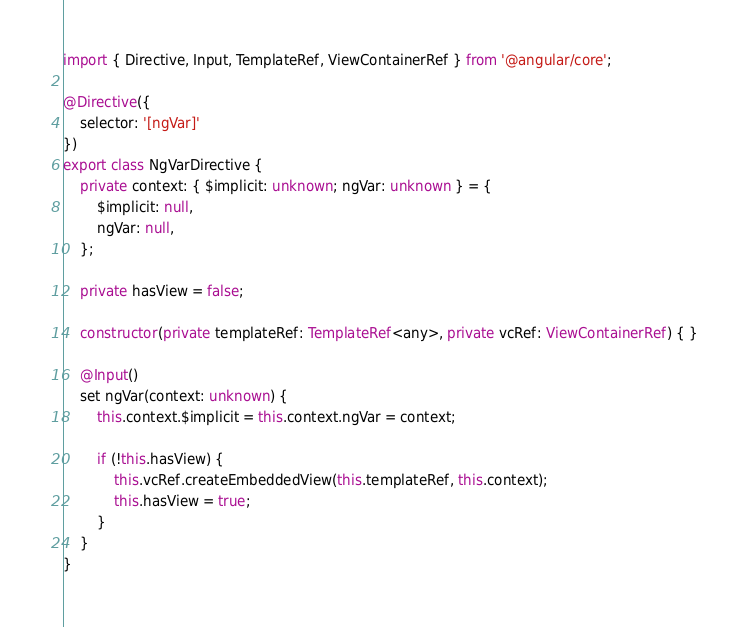Convert code to text. <code><loc_0><loc_0><loc_500><loc_500><_TypeScript_>import { Directive, Input, TemplateRef, ViewContainerRef } from '@angular/core';

@Directive({
	selector: '[ngVar]'
})
export class NgVarDirective {
	private context: { $implicit: unknown; ngVar: unknown } = {
		$implicit: null,
		ngVar: null,
	};

	private hasView = false;

	constructor(private templateRef: TemplateRef<any>, private vcRef: ViewContainerRef) { }

	@Input()
	set ngVar(context: unknown) {
		this.context.$implicit = this.context.ngVar = context;

		if (!this.hasView) {
			this.vcRef.createEmbeddedView(this.templateRef, this.context);
			this.hasView = true;
		}
	}
}
</code> 